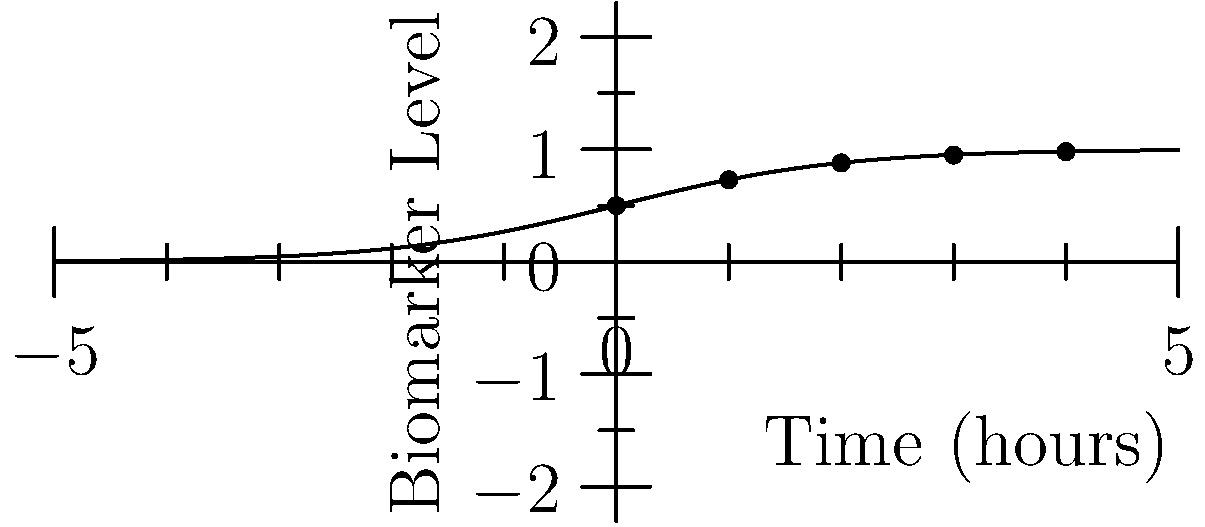As a healthcare pioneer, you're analyzing a new biomarker test for early disease detection. The graph shows the relationship between time and biomarker levels in patients. What mathematical function best describes this pattern, and what does it imply about the biomarker's behavior over time? To identify the function and understand its implications:

1. Observe the graph's shape: It starts near zero, rises steeply, then levels off asymptotically.

2. Recognize this as a sigmoid curve, common in biological processes.

3. The specific sigmoid function here is the logistic function, given by:

   $$f(x) = \frac{1}{1 + e^{-x}}$$

4. This function has several important properties:
   a) It's bounded between 0 and 1
   b) It has a symmetrical S-shape
   c) The steepest growth occurs around x = 0

5. In the context of biomarkers:
   a) The x-axis represents time since the test began
   b) The y-axis represents the biomarker concentration

6. Implications for biomarker behavior:
   a) Initially, the biomarker level increases slowly
   b) There's a period of rapid increase
   c) The level eventually plateaus, approaching a maximum

7. This pattern suggests:
   a) The biomarker has a natural upper limit
   b) The rate of production or accumulation varies over time
   c) The test may be most sensitive during the steep part of the curve

Understanding this pattern allows for optimal timing of tests and interpretation of results in early disease detection.
Answer: Logistic function; implies sigmoid growth with upper limit 